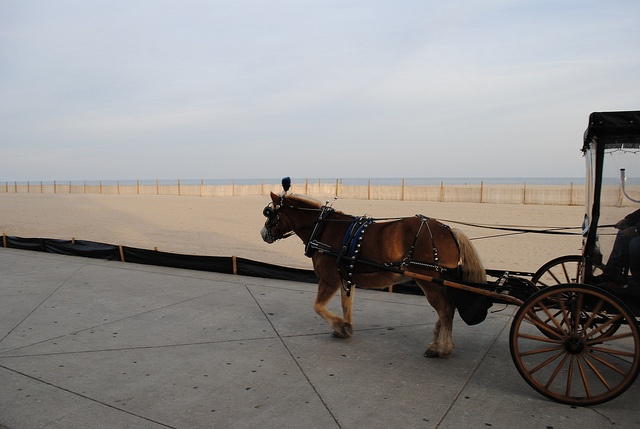Describe the objects in this image and their specific colors. I can see horse in lightgray, black, maroon, and gray tones and people in lightgray, black, and gray tones in this image. 